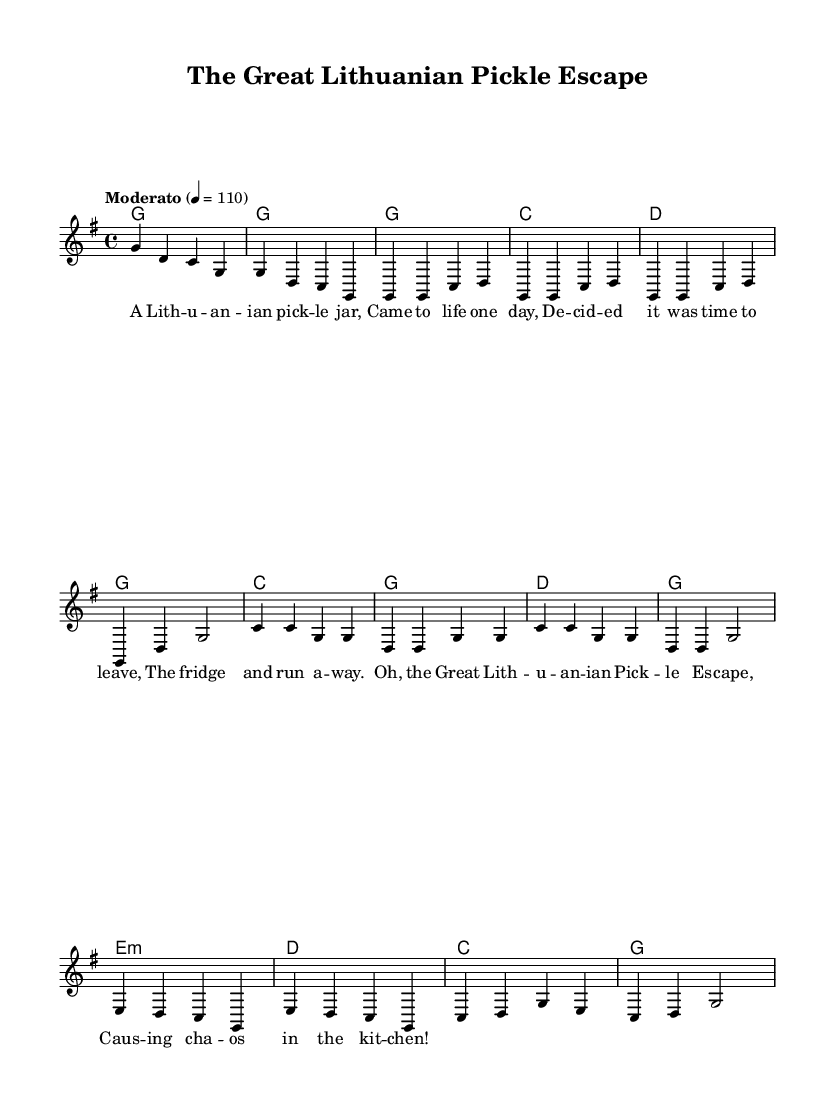What is the key signature of this music? The key signature shown in the sheet music indicates two sharps, which corresponds to the key of D major. However, the context and chords indicate G major is intended, which has one sharp (F#).
Answer: G major What is the time signature of this music? The time signature indicated at the beginning of the sheet music is 4/4, meaning there are four beats in each measure and the quarter note receives one beat.
Answer: 4/4 What is the tempo marking for this piece? The tempo marking at the beginning of the sheet music is "Moderato" with a metronome marking of 110, indicating a moderate speed.
Answer: Moderato How many measures are in the verse section? By counting the measures in the verse portion of the sheet music, we find there are four measures that make up the verse.
Answer: 4 What is the chord progression for the chorus? The chorus consists of the following chords in order: C, G, D, G, repeated for the four measures as indicated in the harmonies section.
Answer: C, G, D, G What kind of story does the lyrics tell in this folk tune? The lyrics narrate an absurd situation where a Lithuanian pickle jar decides to escape the fridge, creating chaos in the kitchen, characteristic of quirky Americana folk tunes.
Answer: A pickle escaping 